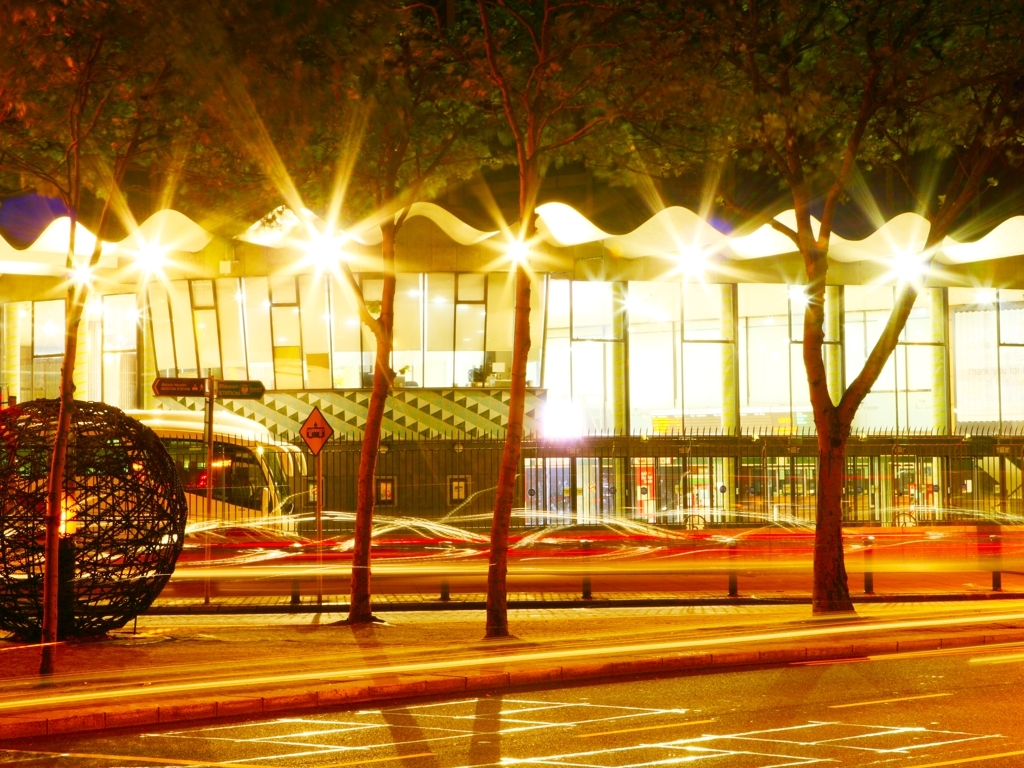Does this photo have a high level of clarity?
A. Yes
B. No
Answer with the option's letter from the given choices directly.
 A. 